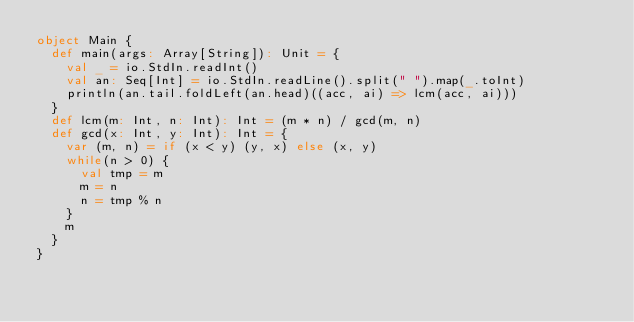<code> <loc_0><loc_0><loc_500><loc_500><_Scala_>object Main {
  def main(args: Array[String]): Unit = {
    val _ = io.StdIn.readInt()
    val an: Seq[Int] = io.StdIn.readLine().split(" ").map(_.toInt)
    println(an.tail.foldLeft(an.head)((acc, ai) => lcm(acc, ai)))
  }
  def lcm(m: Int, n: Int): Int = (m * n) / gcd(m, n)
  def gcd(x: Int, y: Int): Int = {
    var (m, n) = if (x < y) (y, x) else (x, y)
    while(n > 0) {
      val tmp = m
      m = n
      n = tmp % n
    }
    m
  }
}</code> 